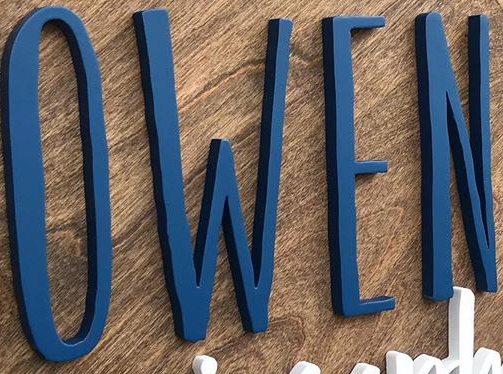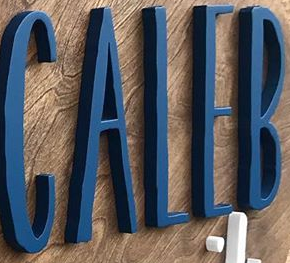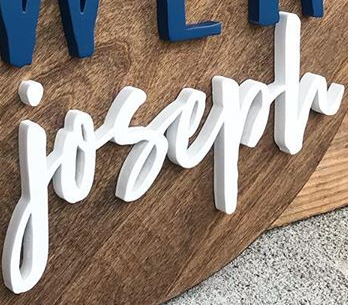Identify the words shown in these images in order, separated by a semicolon. OWEN; CALEB; joseph 